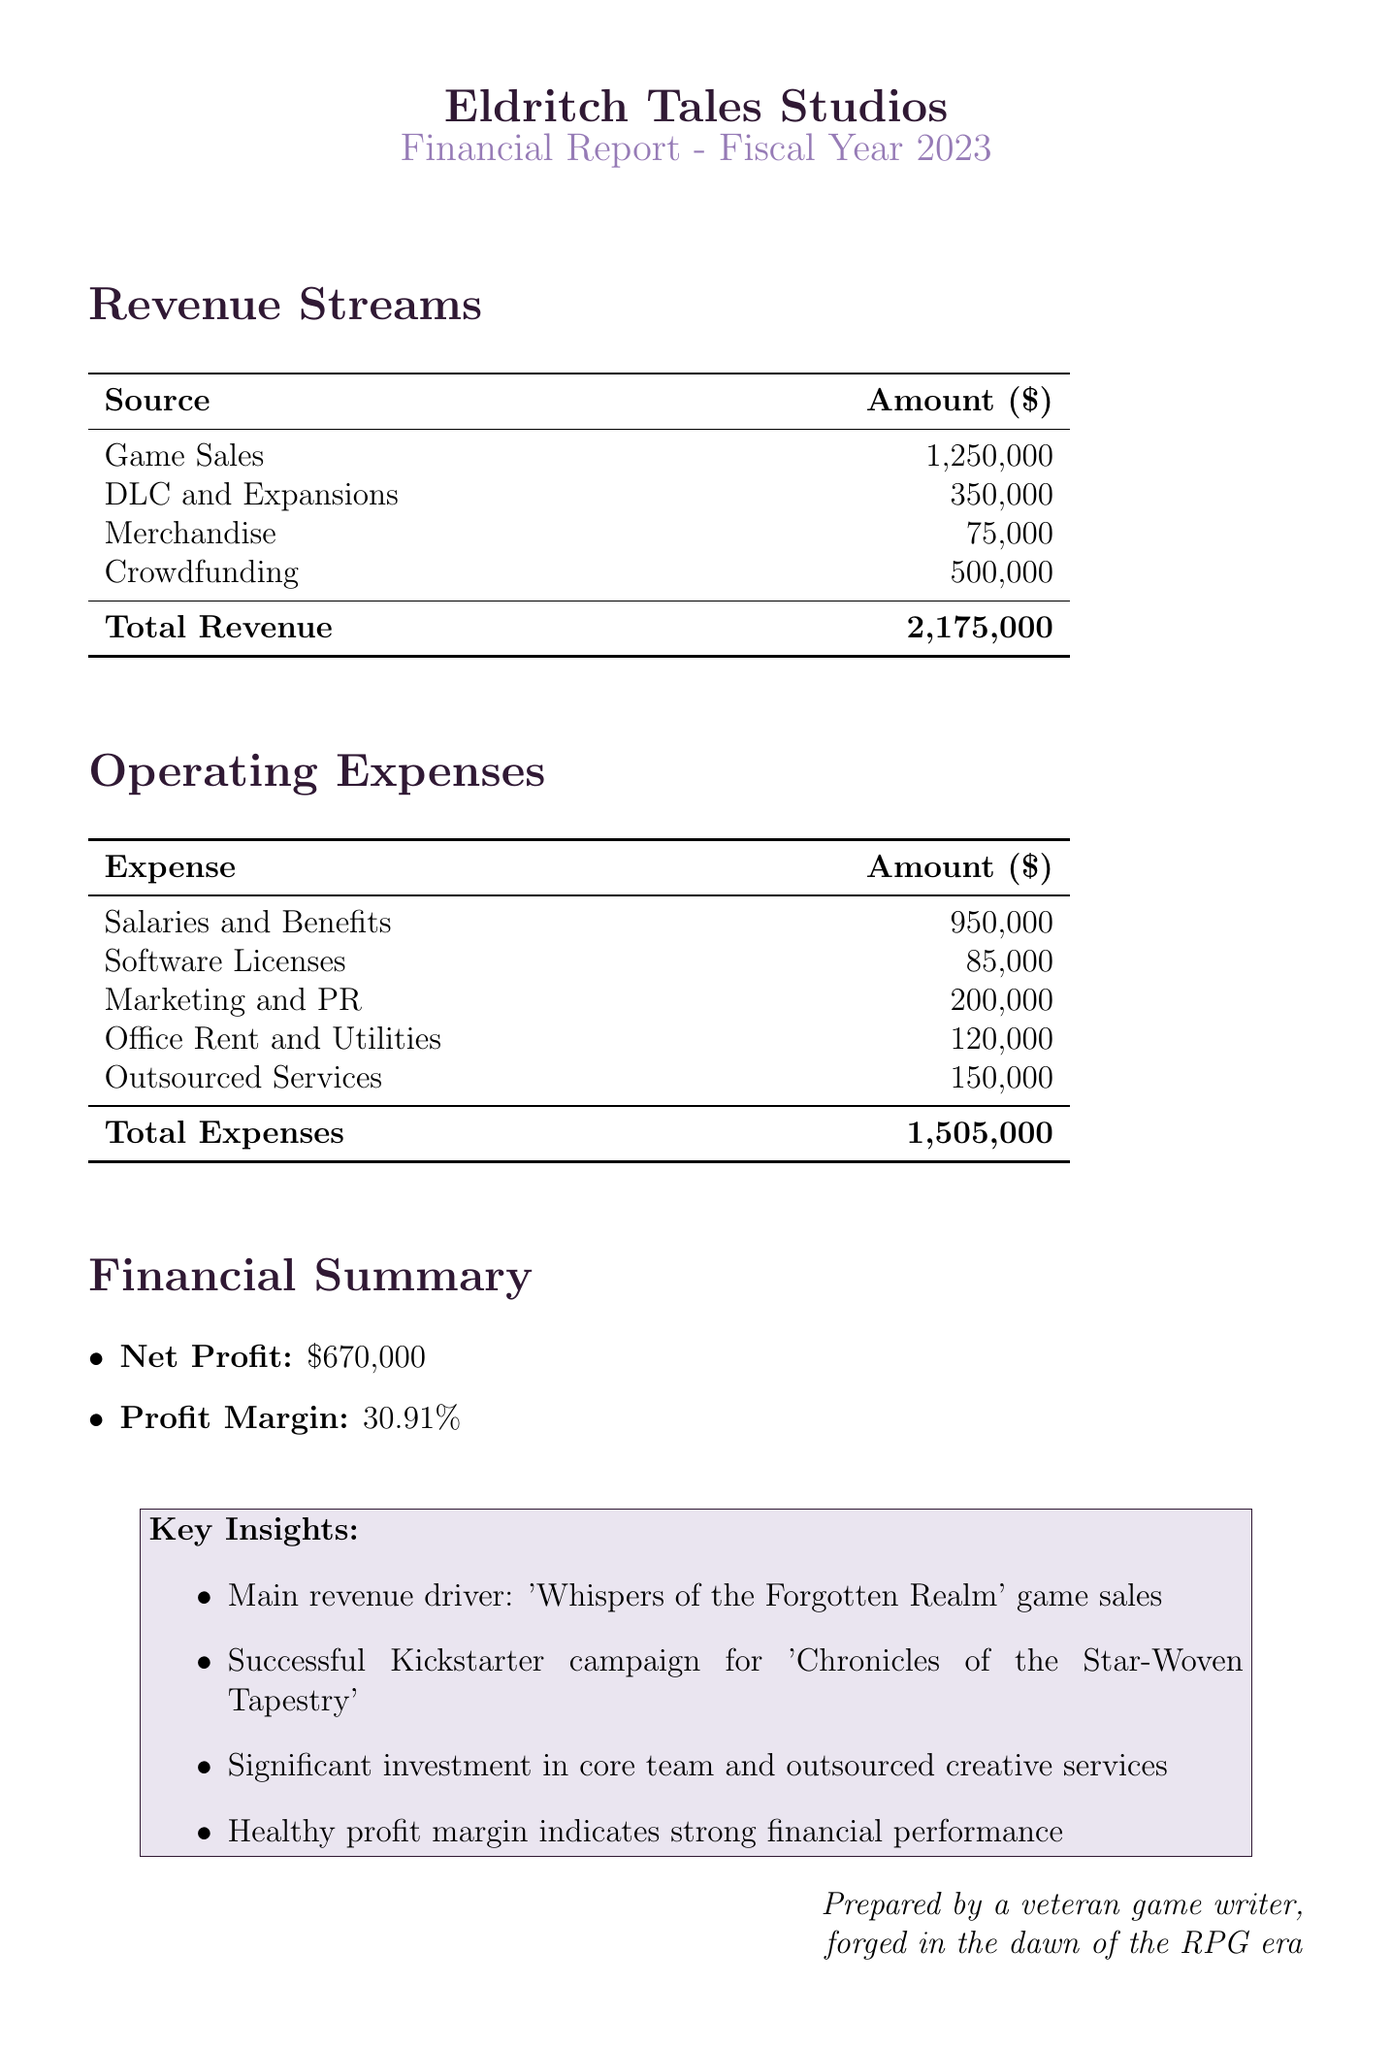What is the studio name? The studio name is stated at the beginning of the document.
Answer: Eldritch Tales Studios What is the revenue from game sales? This figure is listed in the revenue streams section for game sales.
Answer: 1,250,000 How much did the crowdfunding campaign generate? The amount from the crowdfunding campaign is provided in the revenue streams section.
Answer: 500,000 What are the total operating expenses? The total operating expenses are calculated by summing all the expenses listed in the document.
Answer: 1,505,000 What is the net profit? The net profit is specifically mentioned in the financial summary section of the document.
Answer: 670,000 What is the profit margin percentage? The profit margin percentage is presented in the financial summary as well.
Answer: 30.91% Which revenue source is the main driver? The document mentions this in the key insights under financial summary.
Answer: 'Whispers of the Forgotten Realm' game sales What is the total amount from DLC and expansions? This figure is highlighted in the revenue streams section of the document.
Answer: 350,000 What expense category has the highest amount? This can be determined by comparing all operating expenses listed.
Answer: Salaries and Benefits 